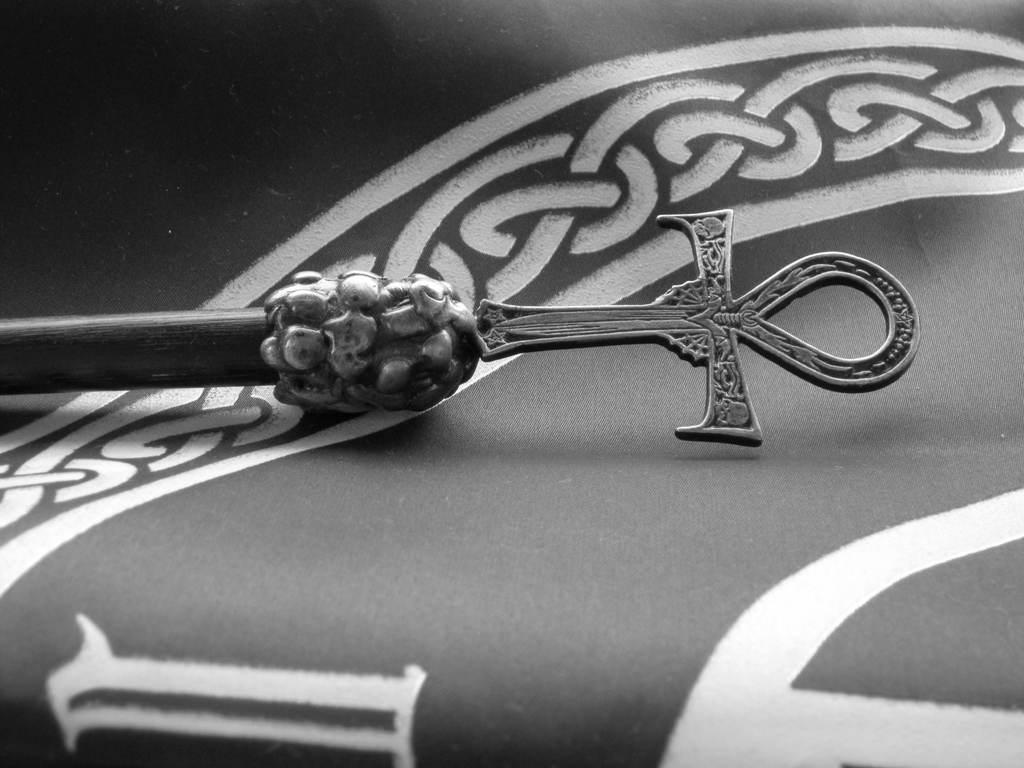What is the color scheme of the image? The image is black and white. What is the main object or symbol in the image? There is a cross symbol on a small stick in the image. Where is the cross symbol located? The cross symbol is on a banner. How many boats are visible on the floor in the image? There are no boats visible in the image, and the image does not depict a floor. 